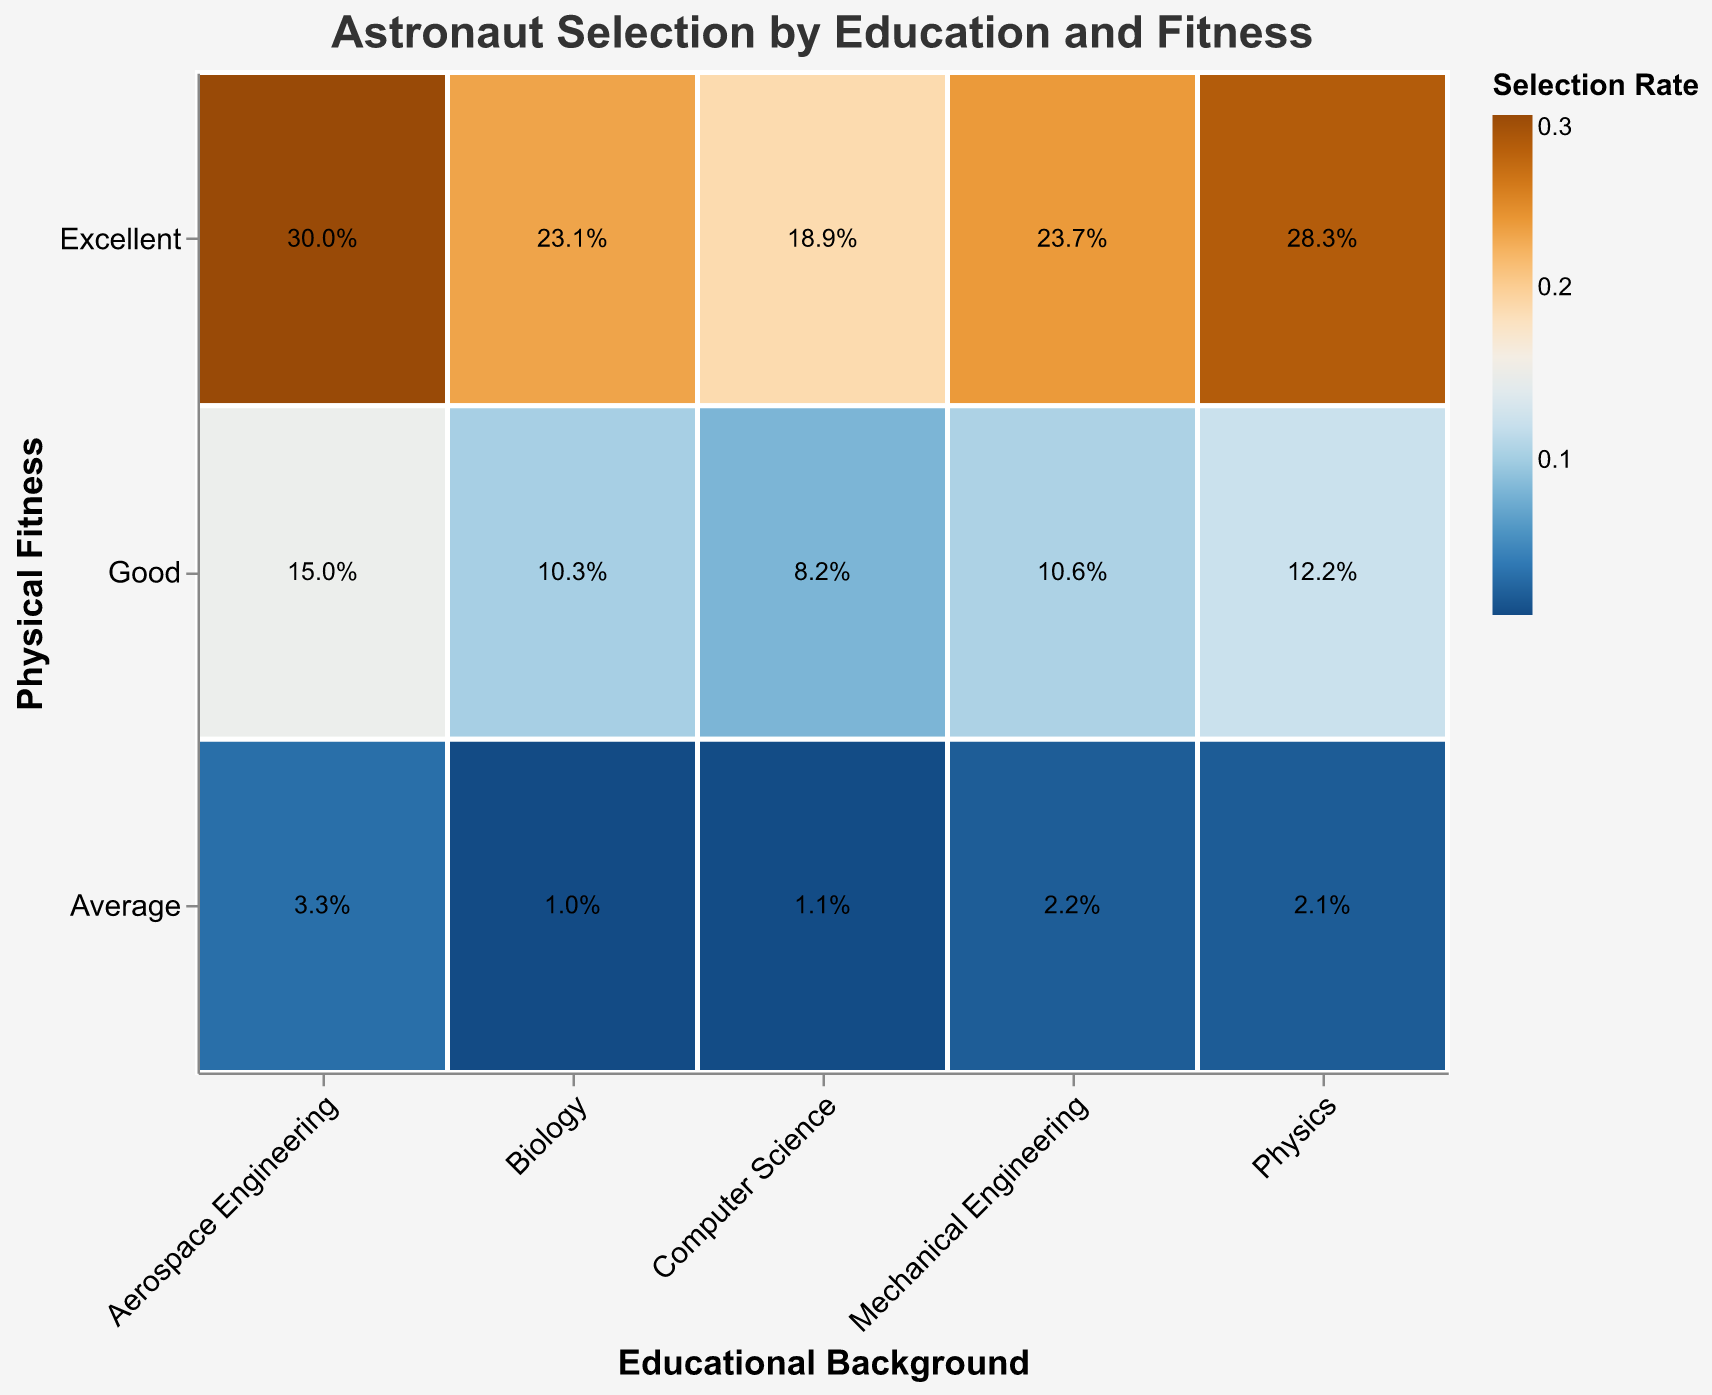What is the color representing the highest selection rate? The color scale indicates different selection rates using a scheme from blue to orange. The highest selection rate is represented by the most brightly colored part of the scale, which is a vivid shade of orange.
Answer: vivid orange Which educational background and physical fitness combination has the highest selection rate? To determine this, look for the cell with the most vivid orange color. The "Aerospace Engineering" with "Excellent" physical fitness has the highest selection rate, as it is most brightly colored.
Answer: Aerospace Engineering with Excellent physical fitness How many people with a background in Physics and Excellent physical fitness were selected? Look at the specific cell for "Physics" with "Excellent" physical fitness and use the tooltip or the text annotation in the cell. The text annotation in this cell is "28.3%", and it corresponds to 15 people selected out of the total number.
Answer: 15 What is the selection rate for Mechanical Engineering with Average physical fitness? Find the "Mechanical Engineering" row and the "Average" column. The intersection shows the specific selection rate. The text annotation reads “2.2%,” which means that the selection rate is approximately 2.2%.
Answer: 2.2% How does the selection rate for Computer Science with Good physical fitness compare to that of Physics with Good physical fitness? Compare the two cells at the intersection of "Good" physical fitness and "Computer Science" vs. "Physics". "Computer Science" has a selection rate of 8.2%, and "Physics" has a selection rate of 12.2%. Physics has a higher selection rate.
Answer: Physics > Computer Science What educational background has the lowest selection rate for excellent physical fitness? Compare the cells in the "Excellent" physical fitness row. The lowest rate among them is for "Computer Science" which has a rate of approximately 18.9%
Answer: Computer Science Which physical fitness category generally shows the highest selection rates across all educational backgrounds? Look across the "Excellent", "Good", and "Average" rows. The "Excellent" physical fitness row consistently shows higher selection rates across different educational backgrounds.
Answer: Excellent What is the selection rate difference between Aerospace Engineering with Good physical fitness and Biology with Excellent physical fitness? The selection rate for Aerospace Engineering with Good fitness is approximately 15.0%, and for Biology with Excellent fitness, it is 23.1%. The difference is 23.1% - 15.0% = 8.1%.
Answer: 8.1% How does the selection rate trend with physical fitness level for the Mechanical Engineering background? Check the selection rates across "Excellent", "Good", and "Average" physical fitness levels for "Mechanical Engineering". The rates decrease from Excellent (23.7%), to Good (10.6%), to Average (2.2%). This indicates a declining trend as fitness level decreases.
Answer: Decreasing trend 